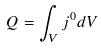<formula> <loc_0><loc_0><loc_500><loc_500>Q = \int _ { V } j ^ { 0 } d V</formula> 